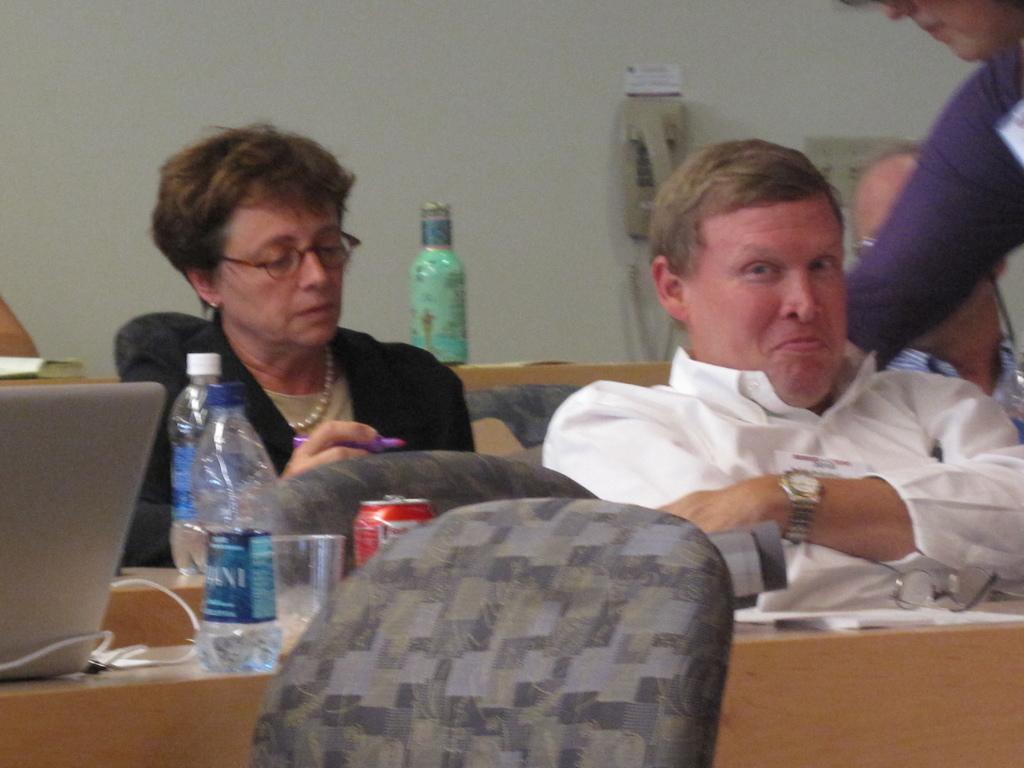What is the color of the wall in the image? The wall in the image is white. What are the people in the image doing? The people in the image are sitting. What is on the table in the image? There is a table in the image with bottles and a laptop on it. What type of leaf is falling from the roof in the image? There is no roof or leaf present in the image. What color is the underwear of the person sitting in the image? The provided facts do not mention any underwear, so we cannot determine its color. 